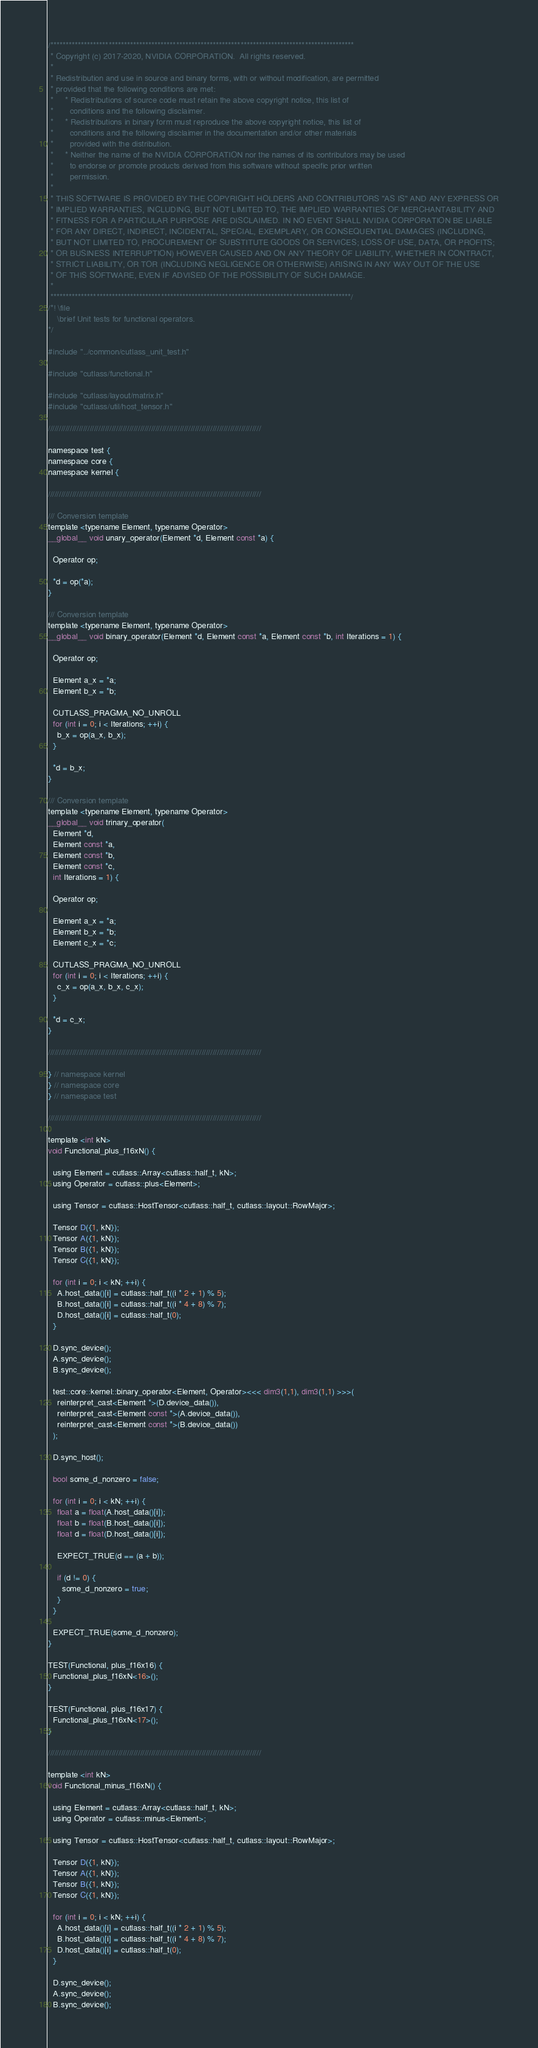Convert code to text. <code><loc_0><loc_0><loc_500><loc_500><_Cuda_>/***************************************************************************************************
 * Copyright (c) 2017-2020, NVIDIA CORPORATION.  All rights reserved.
 *
 * Redistribution and use in source and binary forms, with or without modification, are permitted
 * provided that the following conditions are met:
 *     * Redistributions of source code must retain the above copyright notice, this list of
 *       conditions and the following disclaimer.
 *     * Redistributions in binary form must reproduce the above copyright notice, this list of
 *       conditions and the following disclaimer in the documentation and/or other materials
 *       provided with the distribution.
 *     * Neither the name of the NVIDIA CORPORATION nor the names of its contributors may be used
 *       to endorse or promote products derived from this software without specific prior written
 *       permission.
 *
 * THIS SOFTWARE IS PROVIDED BY THE COPYRIGHT HOLDERS AND CONTRIBUTORS "AS IS" AND ANY EXPRESS OR
 * IMPLIED WARRANTIES, INCLUDING, BUT NOT LIMITED TO, THE IMPLIED WARRANTIES OF MERCHANTABILITY AND
 * FITNESS FOR A PARTICULAR PURPOSE ARE DISCLAIMED. IN NO EVENT SHALL NVIDIA CORPORATION BE LIABLE
 * FOR ANY DIRECT, INDIRECT, INCIDENTAL, SPECIAL, EXEMPLARY, OR CONSEQUENTIAL DAMAGES (INCLUDING,
 * BUT NOT LIMITED TO, PROCUREMENT OF SUBSTITUTE GOODS OR SERVICES; LOSS OF USE, DATA, OR PROFITS;
 * OR BUSINESS INTERRUPTION) HOWEVER CAUSED AND ON ANY THEORY OF LIABILITY, WHETHER IN CONTRACT,
 * STRICT LIABILITY, OR TOR (INCLUDING NEGLIGENCE OR OTHERWISE) ARISING IN ANY WAY OUT OF THE USE
 * OF THIS SOFTWARE, EVEN IF ADVISED OF THE POSSIBILITY OF SUCH DAMAGE.
 *
 **************************************************************************************************/
/*! \file
    \brief Unit tests for functional operators.
*/

#include "../common/cutlass_unit_test.h"

#include "cutlass/functional.h"

#include "cutlass/layout/matrix.h"
#include "cutlass/util/host_tensor.h"

/////////////////////////////////////////////////////////////////////////////////////////////////

namespace test {
namespace core {
namespace kernel {

/////////////////////////////////////////////////////////////////////////////////////////////////

/// Conversion template
template <typename Element, typename Operator>
__global__ void unary_operator(Element *d, Element const *a) {

  Operator op;

  *d = op(*a);
}

/// Conversion template
template <typename Element, typename Operator>
__global__ void binary_operator(Element *d, Element const *a, Element const *b, int Iterations = 1) {

  Operator op;

  Element a_x = *a;
  Element b_x = *b;

  CUTLASS_PRAGMA_NO_UNROLL
  for (int i = 0; i < Iterations; ++i) {
    b_x = op(a_x, b_x);
  }
  
  *d = b_x;
}

/// Conversion template
template <typename Element, typename Operator>
__global__ void trinary_operator(
  Element *d, 
  Element const *a, 
  Element const *b, 
  Element const *c, 
  int Iterations = 1) {

  Operator op;

  Element a_x = *a;
  Element b_x = *b;
  Element c_x = *c;

  CUTLASS_PRAGMA_NO_UNROLL
  for (int i = 0; i < Iterations; ++i) {
    c_x = op(a_x, b_x, c_x);
  }
  
  *d = c_x;
}

/////////////////////////////////////////////////////////////////////////////////////////////////

} // namespace kernel
} // namespace core
} // namespace test

/////////////////////////////////////////////////////////////////////////////////////////////////

template <int kN>
void Functional_plus_f16xN() {

  using Element = cutlass::Array<cutlass::half_t, kN>;
  using Operator = cutlass::plus<Element>;

  using Tensor = cutlass::HostTensor<cutlass::half_t, cutlass::layout::RowMajor>;

  Tensor D({1, kN});
  Tensor A({1, kN});
  Tensor B({1, kN});
  Tensor C({1, kN});

  for (int i = 0; i < kN; ++i) {
    A.host_data()[i] = cutlass::half_t((i * 2 + 1) % 5);
    B.host_data()[i] = cutlass::half_t((i * 4 + 8) % 7);
    D.host_data()[i] = cutlass::half_t(0);
  }

  D.sync_device();
  A.sync_device();
  B.sync_device();

  test::core::kernel::binary_operator<Element, Operator><<< dim3(1,1), dim3(1,1) >>>(
    reinterpret_cast<Element *>(D.device_data()),
    reinterpret_cast<Element const *>(A.device_data()),
    reinterpret_cast<Element const *>(B.device_data())
  );

  D.sync_host();

  bool some_d_nonzero = false;

  for (int i = 0; i < kN; ++i) {
    float a = float(A.host_data()[i]);
    float b = float(B.host_data()[i]);
    float d = float(D.host_data()[i]);

    EXPECT_TRUE(d == (a + b));

    if (d != 0) {
      some_d_nonzero = true;
    }
  }

  EXPECT_TRUE(some_d_nonzero);
}

TEST(Functional, plus_f16x16) {
  Functional_plus_f16xN<16>();
}

TEST(Functional, plus_f16x17) {
  Functional_plus_f16xN<17>();
}

/////////////////////////////////////////////////////////////////////////////////////////////////

template <int kN>
void Functional_minus_f16xN() {

  using Element = cutlass::Array<cutlass::half_t, kN>;
  using Operator = cutlass::minus<Element>;

  using Tensor = cutlass::HostTensor<cutlass::half_t, cutlass::layout::RowMajor>;

  Tensor D({1, kN});
  Tensor A({1, kN});
  Tensor B({1, kN});
  Tensor C({1, kN});

  for (int i = 0; i < kN; ++i) {
    A.host_data()[i] = cutlass::half_t((i * 2 + 1) % 5);
    B.host_data()[i] = cutlass::half_t((i * 4 + 8) % 7);
    D.host_data()[i] = cutlass::half_t(0);
  }

  D.sync_device();
  A.sync_device();
  B.sync_device();
</code> 